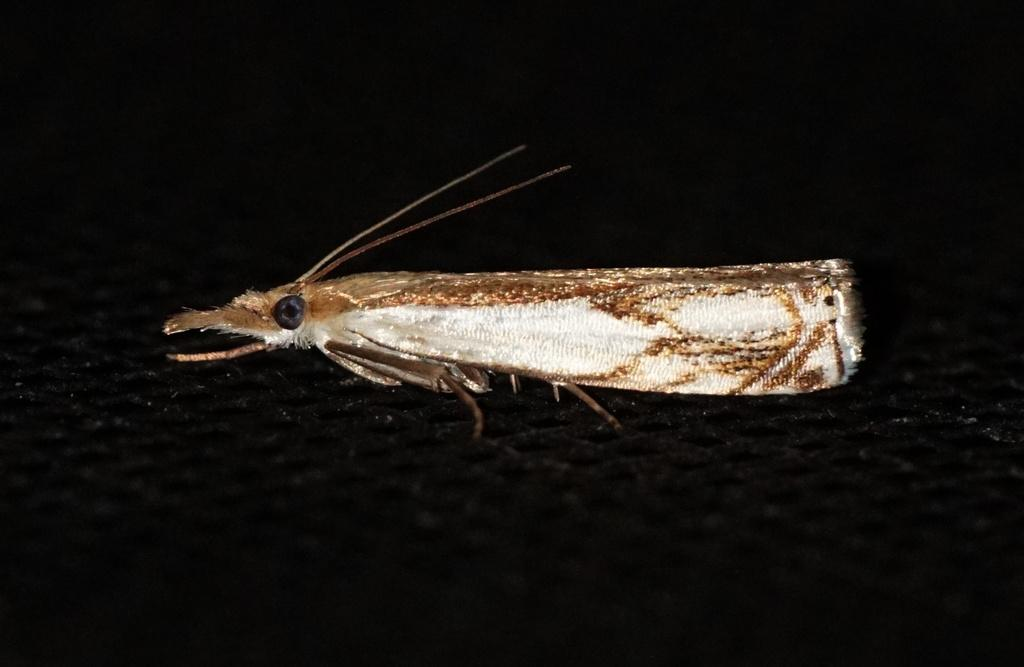What is the overall color scheme of the image? The background of the image is dark. What can be seen in the middle of the image? There is a fly in the middle of the image. How many clocks are visible in the image? There are no clocks present in the image; it only features a fly in a dark background. 